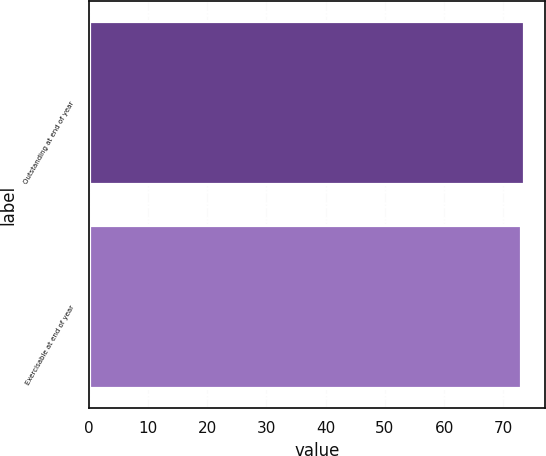Convert chart. <chart><loc_0><loc_0><loc_500><loc_500><bar_chart><fcel>Outstanding at end of year<fcel>Exercisable at end of year<nl><fcel>73.44<fcel>72.94<nl></chart> 